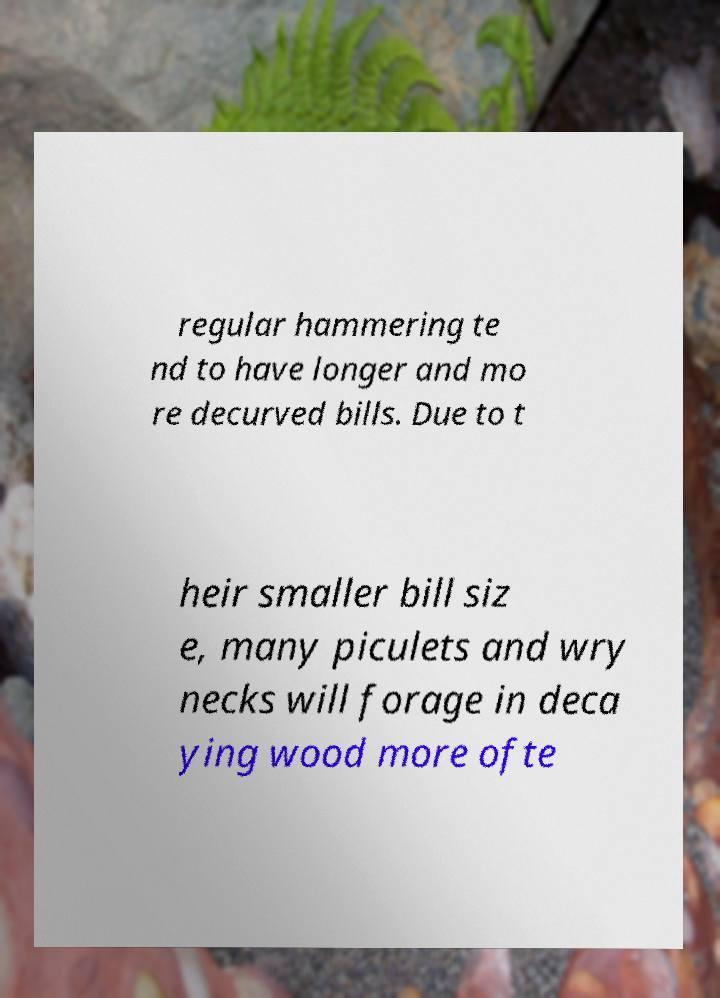Please identify and transcribe the text found in this image. regular hammering te nd to have longer and mo re decurved bills. Due to t heir smaller bill siz e, many piculets and wry necks will forage in deca ying wood more ofte 